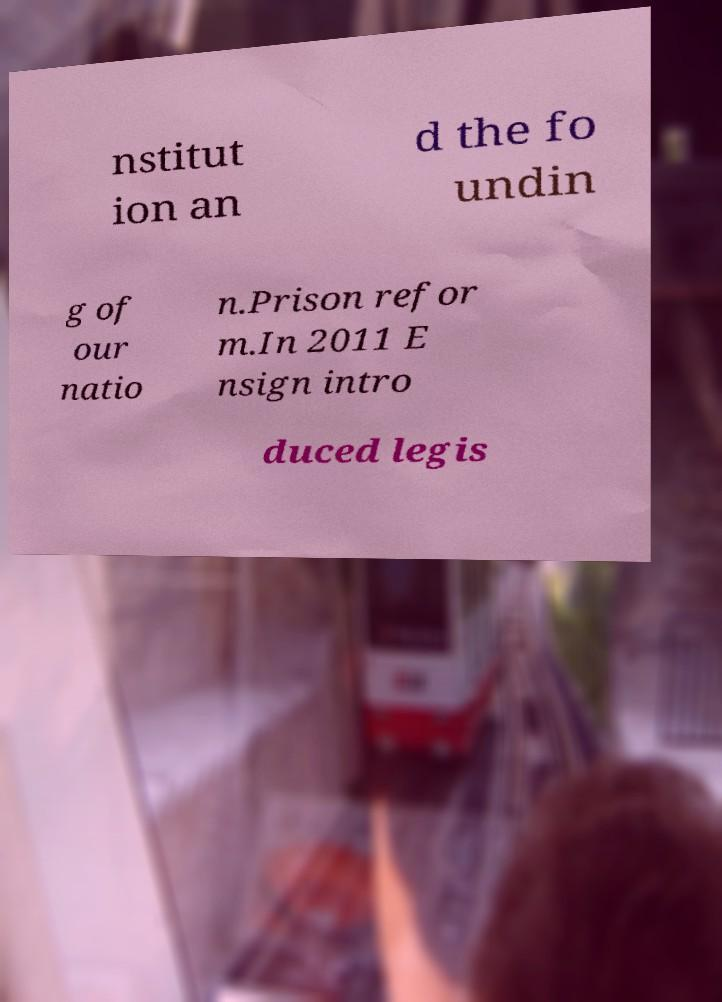Could you assist in decoding the text presented in this image and type it out clearly? nstitut ion an d the fo undin g of our natio n.Prison refor m.In 2011 E nsign intro duced legis 